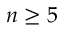<formula> <loc_0><loc_0><loc_500><loc_500>n \geq 5</formula> 